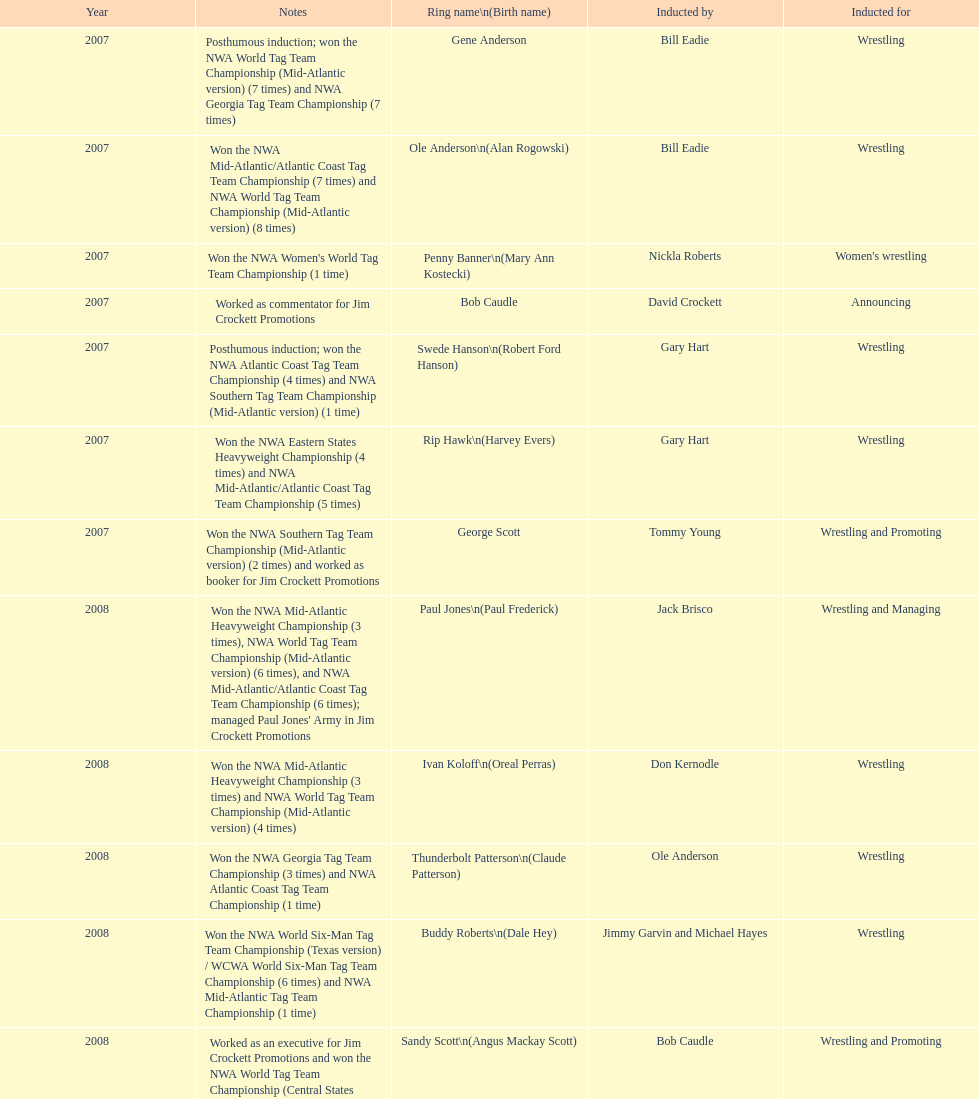Tell me an inductee that was not living at the time. Gene Anderson. 